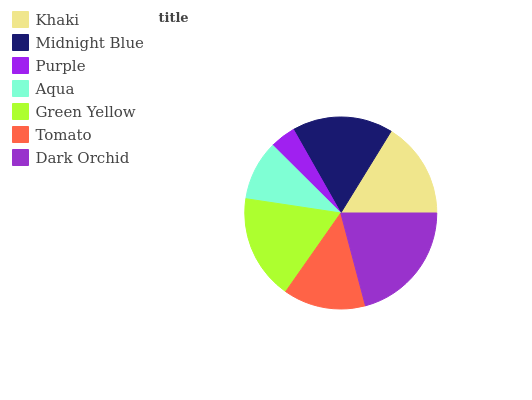Is Purple the minimum?
Answer yes or no. Yes. Is Dark Orchid the maximum?
Answer yes or no. Yes. Is Midnight Blue the minimum?
Answer yes or no. No. Is Midnight Blue the maximum?
Answer yes or no. No. Is Midnight Blue greater than Khaki?
Answer yes or no. Yes. Is Khaki less than Midnight Blue?
Answer yes or no. Yes. Is Khaki greater than Midnight Blue?
Answer yes or no. No. Is Midnight Blue less than Khaki?
Answer yes or no. No. Is Khaki the high median?
Answer yes or no. Yes. Is Khaki the low median?
Answer yes or no. Yes. Is Aqua the high median?
Answer yes or no. No. Is Purple the low median?
Answer yes or no. No. 